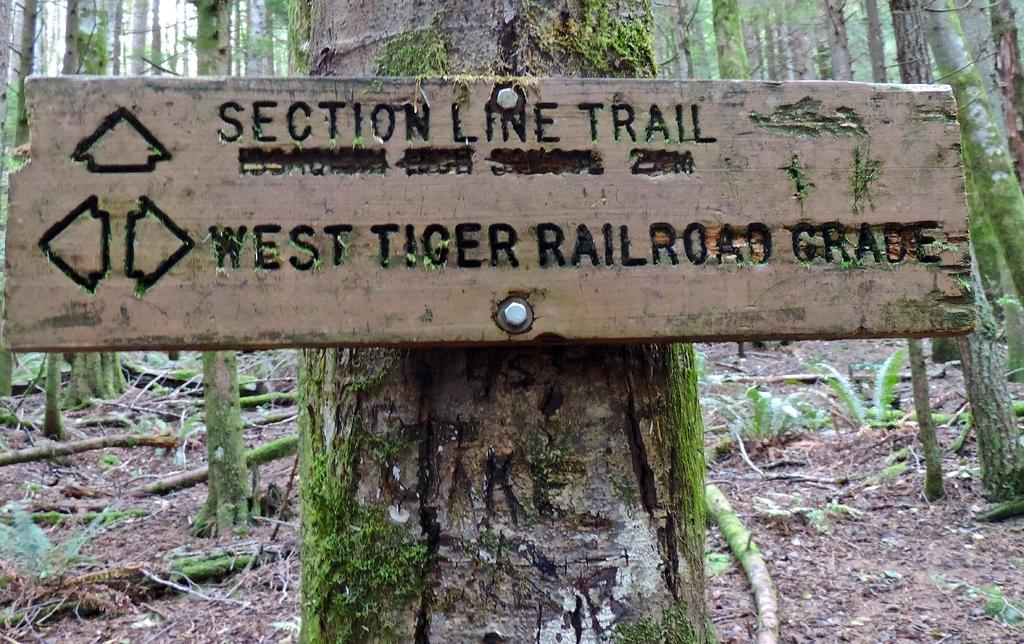What type of board is visible in the image? There is a wooden caution board in the image. How is the caution board positioned in the image? The caution board is attached to a tree trunk. What can be seen in the background of the image? There are many tall trees in the background of the image. What type of yarn is the queen using to knit in the image? There is no queen or yarn present in the image; it features a wooden caution board attached to a tree trunk with tall trees in the background. 